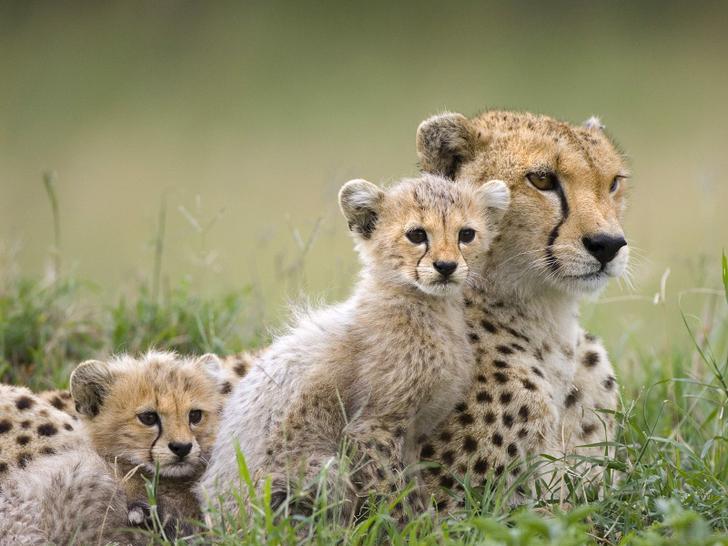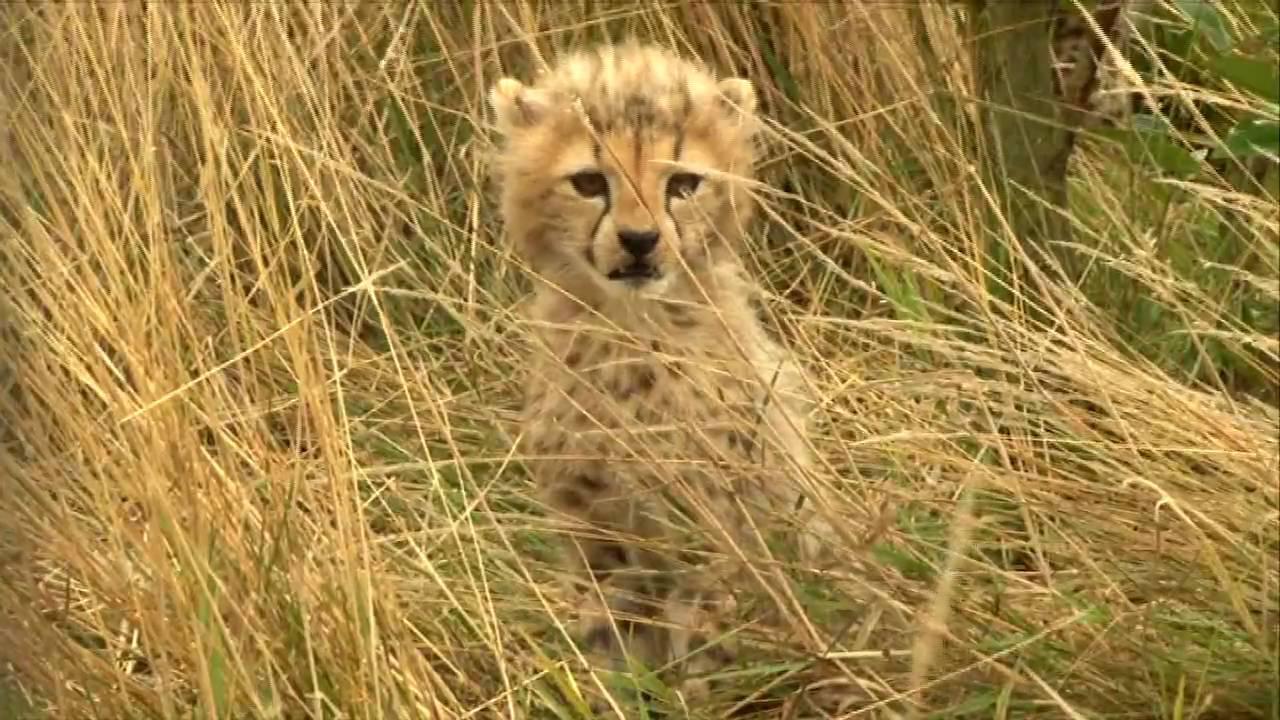The first image is the image on the left, the second image is the image on the right. Examine the images to the left and right. Is the description "The right image contains exactly two baby cheetahs." accurate? Answer yes or no. No. The first image is the image on the left, the second image is the image on the right. Analyze the images presented: Is the assertion "One image shows at least two cheetah kittens to the left of an adult cheetah's face." valid? Answer yes or no. Yes. 